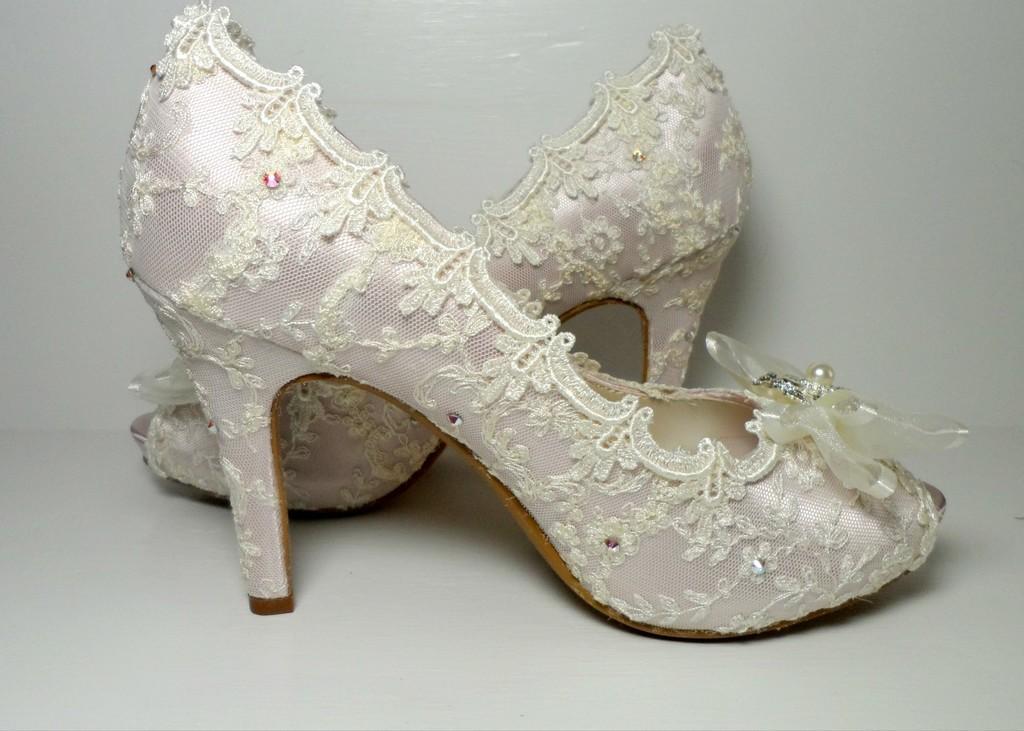Describe this image in one or two sentences. In this image we can see sandals. At the bottom of the image there is white color surface. 